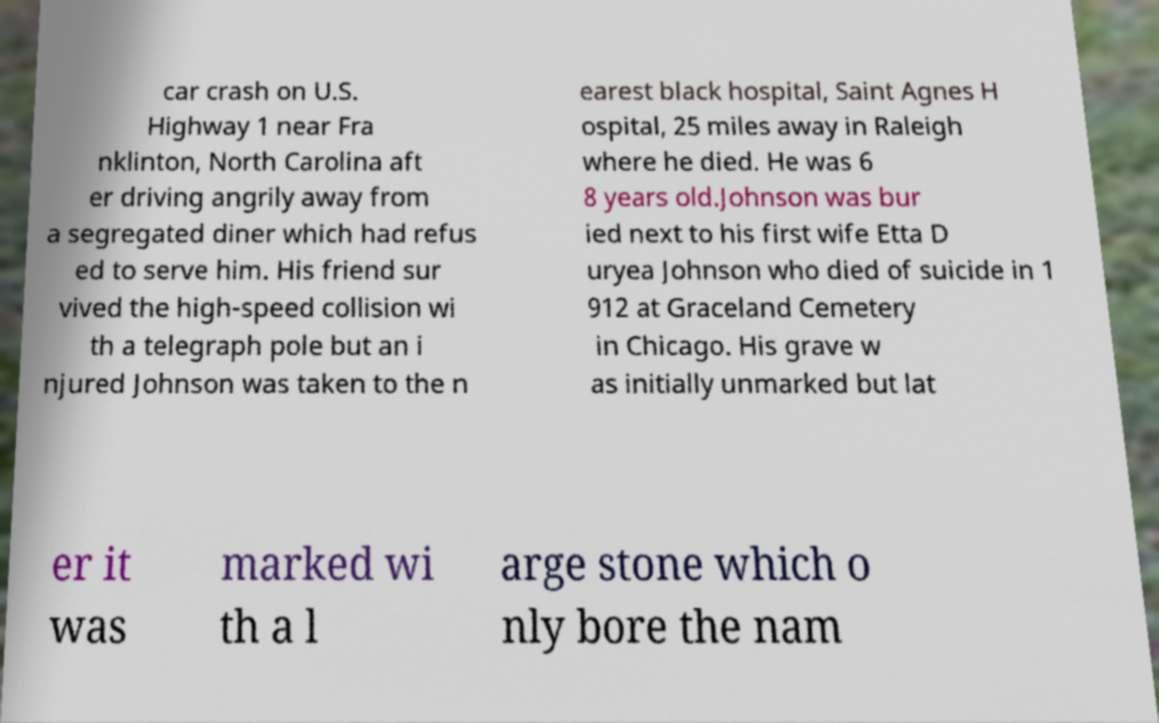For documentation purposes, I need the text within this image transcribed. Could you provide that? car crash on U.S. Highway 1 near Fra nklinton, North Carolina aft er driving angrily away from a segregated diner which had refus ed to serve him. His friend sur vived the high-speed collision wi th a telegraph pole but an i njured Johnson was taken to the n earest black hospital, Saint Agnes H ospital, 25 miles away in Raleigh where he died. He was 6 8 years old.Johnson was bur ied next to his first wife Etta D uryea Johnson who died of suicide in 1 912 at Graceland Cemetery in Chicago. His grave w as initially unmarked but lat er it was marked wi th a l arge stone which o nly bore the nam 